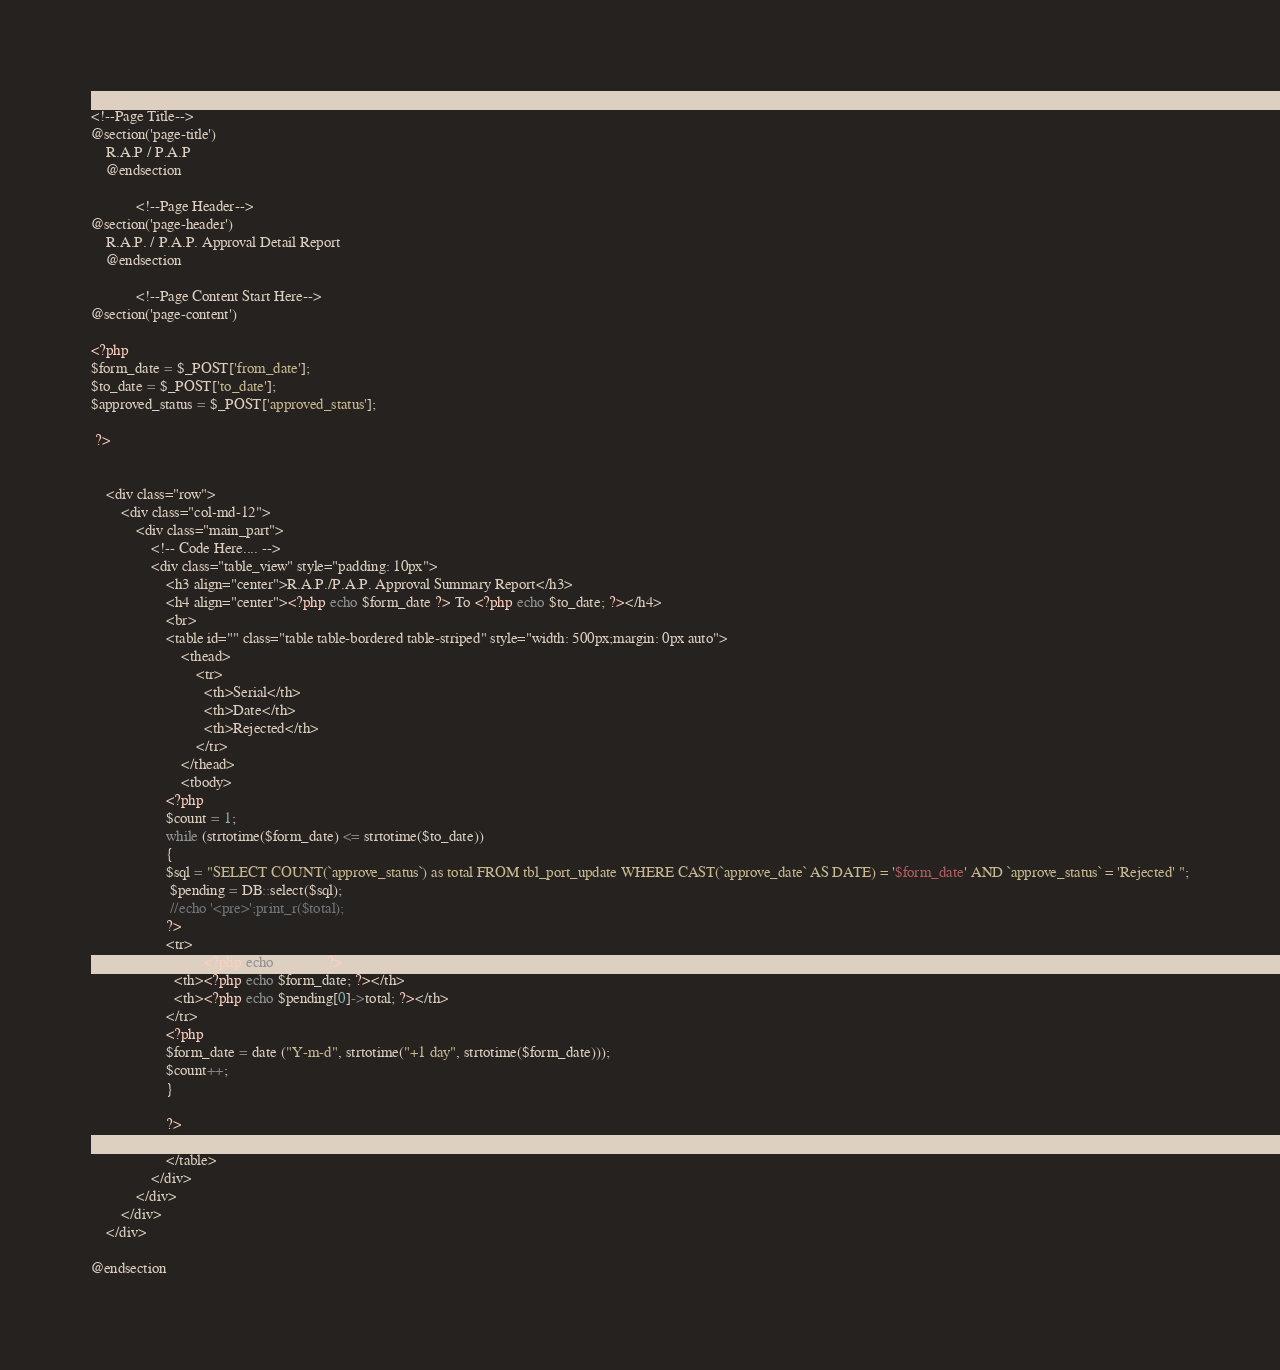<code> <loc_0><loc_0><loc_500><loc_500><_PHP_>@extends('admin.master')
<!--Page Title-->
@section('page-title')
    R.A.P / P.A.P
    @endsection

            <!--Page Header-->
@section('page-header')
    R.A.P. / P.A.P. Approval Detail Report
    @endsection

            <!--Page Content Start Here-->
@section('page-content')

<?php 
$form_date = $_POST['from_date'];
$to_date = $_POST['to_date'];
$approved_status = $_POST['approved_status'];

 ?>


	<div class="row">
		<div class="col-md-12">
			<div class="main_part">
				<!-- Code Here.... -->
				<div class="table_view" style="padding: 10px">
					<h3 align="center">R.A.P./P.A.P. Approval Summary Report</h3>
					<h4 align="center"><?php echo $form_date ?> To <?php echo $to_date; ?></h4>
					<br>
					<table id="" class="table table-bordered table-striped" style="width: 500px;margin: 0px auto">
						<thead>
							<tr>
			                  <th>Serial</th>
			                  <th>Date</th>
			                  <th>Rejected</th>
			                </tr>
						</thead>
						<tbody>
					<?php 
					$count = 1;
					while (strtotime($form_date) <= strtotime($to_date))
					{
					$sql = "SELECT COUNT(`approve_status`) as total FROM tbl_port_update WHERE CAST(`approve_date` AS DATE) = '$form_date' AND `approve_status` = 'Rejected' ";
					 $pending = DB::select($sql);
					 //echo '<pre>';print_r($total);
					?>
					<tr>
	                  <th><?php echo $count; ?></th>
	                  <th><?php echo $form_date; ?></th>
	                  <th><?php echo $pending[0]->total; ?></th>
	                </tr>
					<?php	
					$form_date = date ("Y-m-d", strtotime("+1 day", strtotime($form_date)));
					$count++;
					}

					?>
					</tbody>
					</table>
				</div>
			</div>
		</div>
	</div>

@endsection</code> 